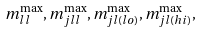Convert formula to latex. <formula><loc_0><loc_0><loc_500><loc_500>m _ { l l } ^ { \max } , m _ { j l l } ^ { \max } , m _ { j l ( l o ) } ^ { \max } , m _ { j l ( h i ) } ^ { \max } ,</formula> 